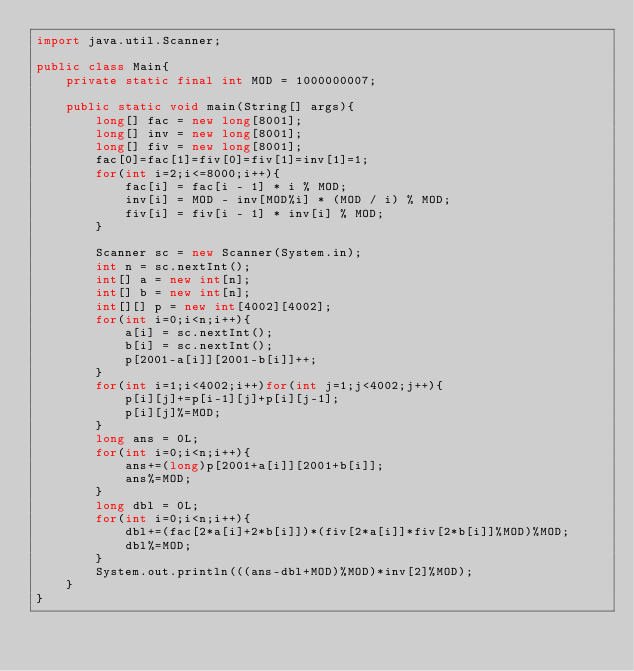<code> <loc_0><loc_0><loc_500><loc_500><_Java_>import java.util.Scanner;

public class Main{
    private static final int MOD = 1000000007;

    public static void main(String[] args){
        long[] fac = new long[8001];
        long[] inv = new long[8001];
        long[] fiv = new long[8001];
        fac[0]=fac[1]=fiv[0]=fiv[1]=inv[1]=1;
        for(int i=2;i<=8000;i++){
            fac[i] = fac[i - 1] * i % MOD;
            inv[i] = MOD - inv[MOD%i] * (MOD / i) % MOD;
            fiv[i] = fiv[i - 1] * inv[i] % MOD;
        }

        Scanner sc = new Scanner(System.in);
        int n = sc.nextInt();
        int[] a = new int[n];
        int[] b = new int[n];
        int[][] p = new int[4002][4002];
        for(int i=0;i<n;i++){
            a[i] = sc.nextInt();
            b[i] = sc.nextInt();
            p[2001-a[i]][2001-b[i]]++;
        }
        for(int i=1;i<4002;i++)for(int j=1;j<4002;j++){
            p[i][j]+=p[i-1][j]+p[i][j-1];
            p[i][j]%=MOD;
        }
        long ans = 0L;
        for(int i=0;i<n;i++){
            ans+=(long)p[2001+a[i]][2001+b[i]];
            ans%=MOD;
        }
        long dbl = 0L;
        for(int i=0;i<n;i++){
            dbl+=(fac[2*a[i]+2*b[i]])*(fiv[2*a[i]]*fiv[2*b[i]]%MOD)%MOD;
            dbl%=MOD;
        }
        System.out.println(((ans-dbl+MOD)%MOD)*inv[2]%MOD);
    }
}</code> 